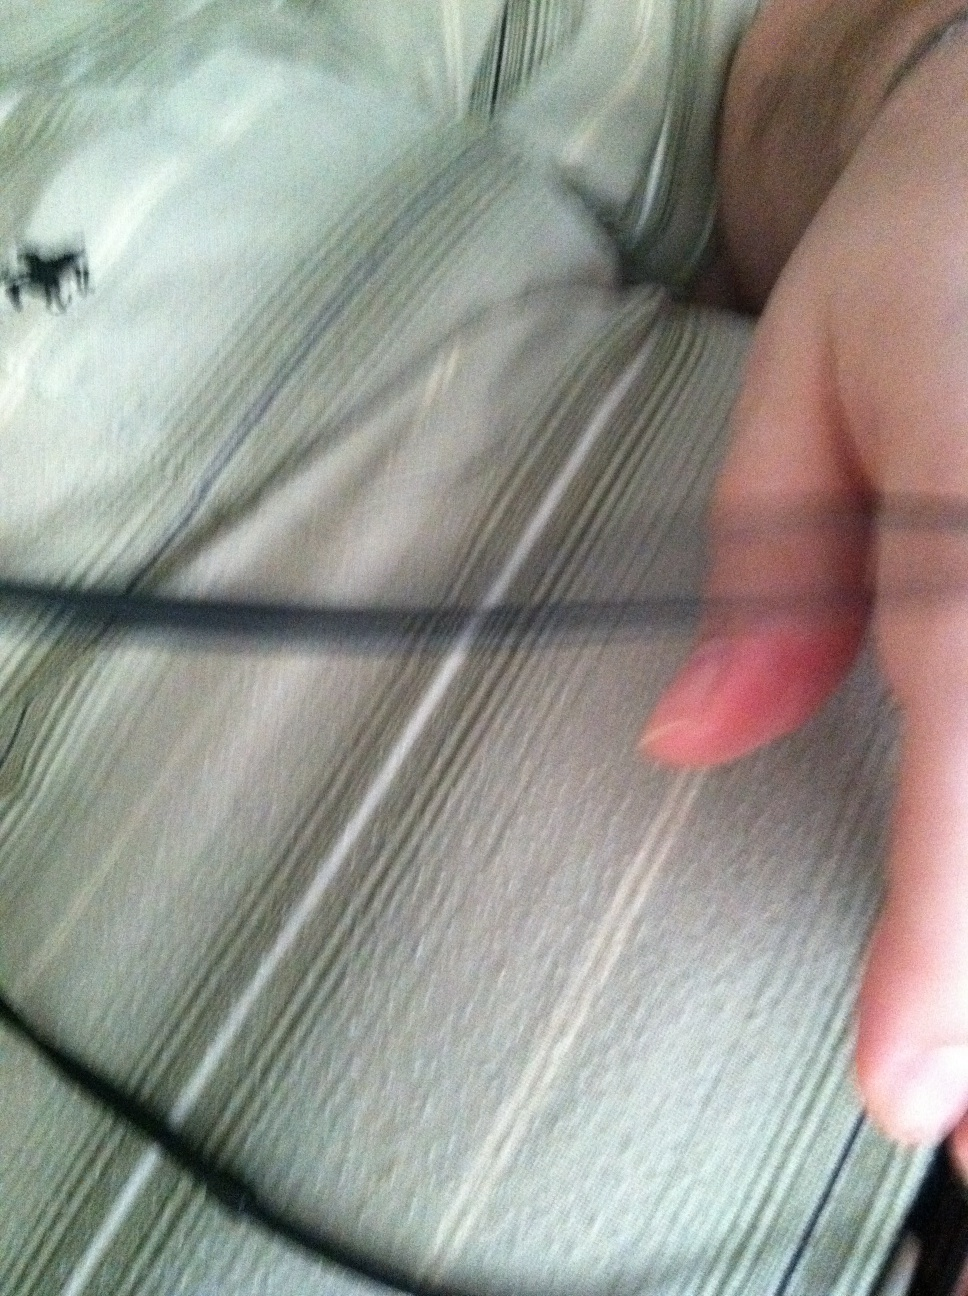Can you describe my shirt in detail? Certainly! Your shirt is grey with horizontal stripes running across it. The fabric appears to be soft, and the stripes give it a clean, structured look. There is also a small design near the top left, possibly a logo or an emblem. 